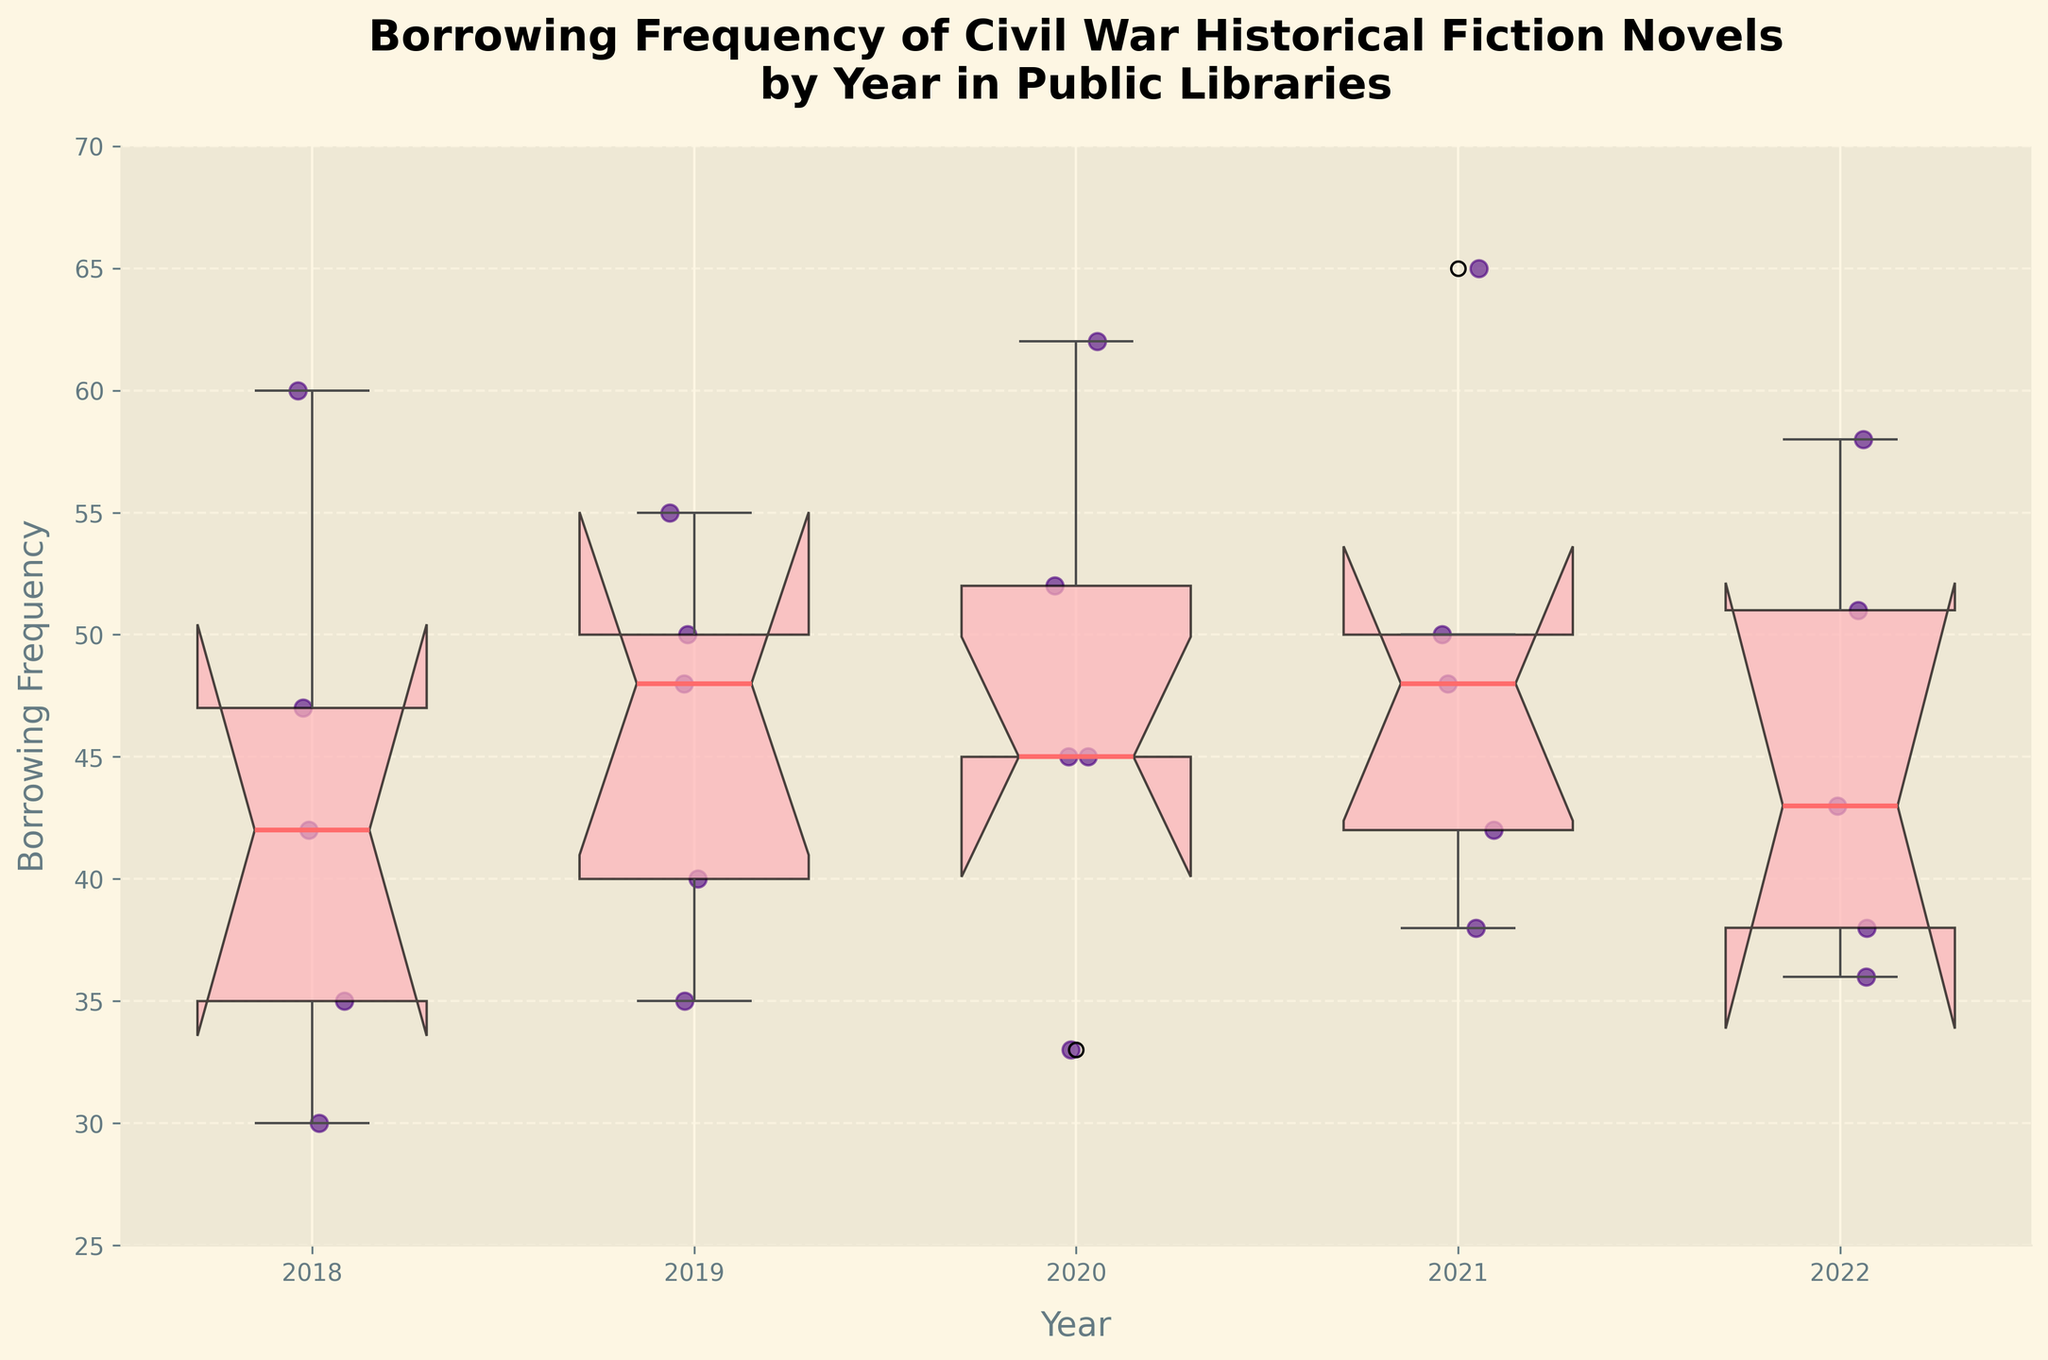What is the title of the figure? The title is shown at the top of the figure in larger and bold text, clearly stating the purpose of the visualization.
Answer: Borrowing Frequency of Civil War Historical Fiction Novels by Year in Public Libraries What does the y-axis represent? The y-axis on the left side of the figure is labeled, indicating what measurement is being represented on this axis.
Answer: Borrowing Frequency Which year has the highest median borrowing frequency? The median of each boxplot is highlighted with a thicker line. By comparing these lines, we can determine which one is the highest.
Answer: 2021 What is the range of borrowing frequencies for 2019? The range is the difference between the maximum and minimum values shown by the whiskers of the boxplot for 2019.
Answer: 35 to 50 What can be said about the borrowing frequency trend from 2018 to 2022? By observing the boxplots for each year in sequence, noting if the medians are increasing, decreasing, or stable, we can infer the trend.
Answer: Generally stable with some fluctuations Which library consistently has the highest borrowing frequency for 'Gone with the Wind'? 'Gone with the Wind' has specific borrowing frequencies each year, which can be checked to see which library shows consistently high values across those years.
Answer: Chicago Public Library How does the interquartile range in 2020 compare to 2018? The interquartile range (IQR) is the difference between the first and third quartiles, which can be assessed by comparing the lengths of the boxes for 2020 and 2018.
Answer: 2020 has a smaller IQR than 2018 Which year shows the widest spread in borrowing frequencies? The spread is indicated by the length of the whiskers and any outliers, so we compare the distances in different years to find the widest.
Answer: 2021 What does a notched boxplot reveal about borrowing frequency comparisons between years? The notches in a boxplot provide a comparison, where overlap indicates no significant difference, and separated notches suggest significant differences.
Answer: Reveals significant or non-significant differences in medians Which book had the highest individual borrowing record from 2018 to 2022? By examining individual data points represented as scatter plots over the years, the highest point can be identified.
Answer: Gone with the Wind in 2021 